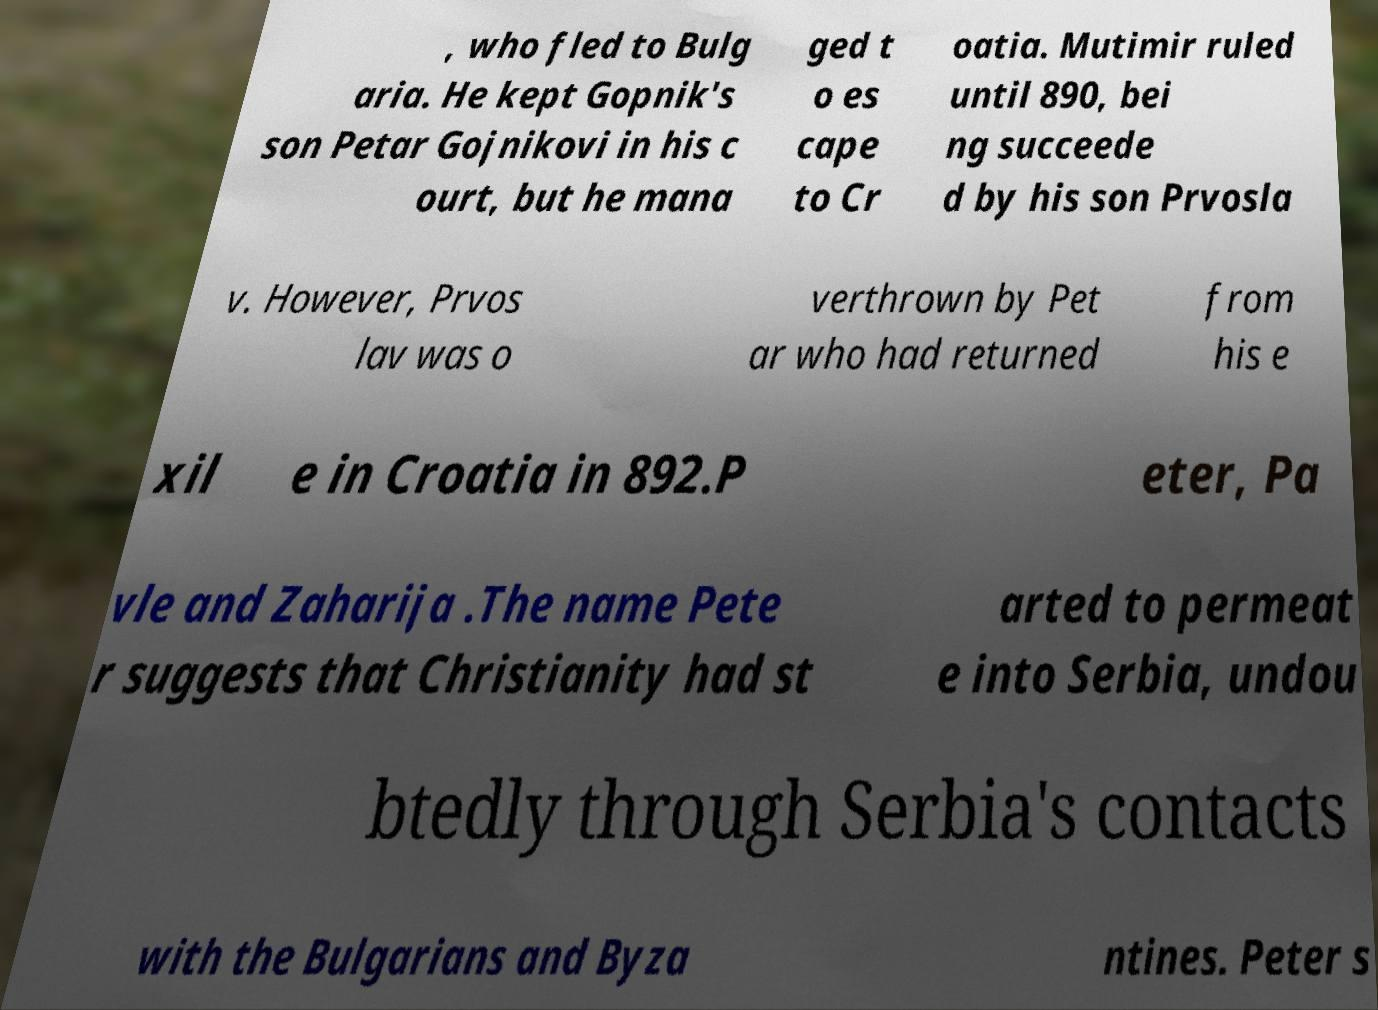Please read and relay the text visible in this image. What does it say? , who fled to Bulg aria. He kept Gopnik's son Petar Gojnikovi in his c ourt, but he mana ged t o es cape to Cr oatia. Mutimir ruled until 890, bei ng succeede d by his son Prvosla v. However, Prvos lav was o verthrown by Pet ar who had returned from his e xil e in Croatia in 892.P eter, Pa vle and Zaharija .The name Pete r suggests that Christianity had st arted to permeat e into Serbia, undou btedly through Serbia's contacts with the Bulgarians and Byza ntines. Peter s 